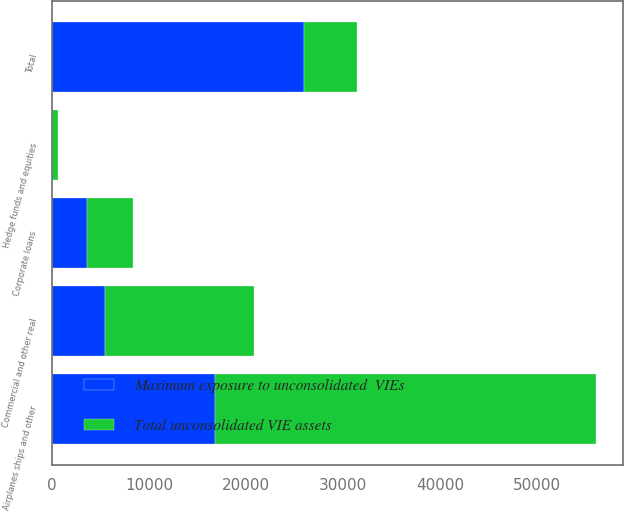Convert chart to OTSL. <chart><loc_0><loc_0><loc_500><loc_500><stacked_bar_chart><ecel><fcel>Commercial and other real<fcel>Corporate loans<fcel>Hedge funds and equities<fcel>Airplanes ships and other<fcel>Total<nl><fcel>Total unconsolidated VIE assets<fcel>15370<fcel>4725<fcel>542<fcel>39202<fcel>5445<nl><fcel>Maximum exposure to unconsolidated  VIEs<fcel>5445<fcel>3587<fcel>58<fcel>16849<fcel>25939<nl></chart> 